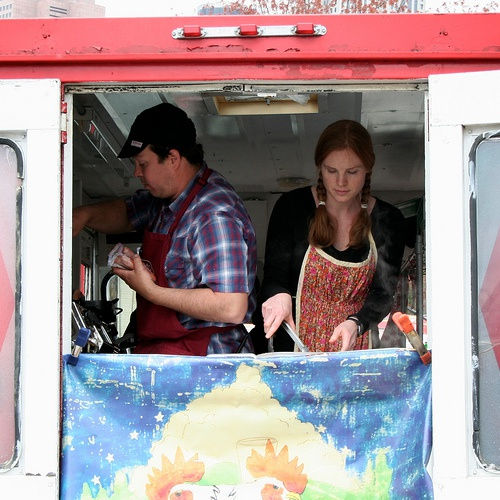Describe the objects in this image and their specific colors. I can see truck in white, black, salmon, gray, and darkgray tones, people in lightgray, black, maroon, gray, and brown tones, people in lightgray, black, brown, maroon, and lightpink tones, hot dog in lightgray, gray, brown, and maroon tones, and spoon in lightgray, black, gray, and white tones in this image. 